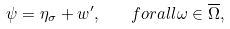<formula> <loc_0><loc_0><loc_500><loc_500>\psi = \eta _ { \sigma } + w ^ { \prime } , \quad f o r a l l \omega \in \overline { \Omega } ,</formula> 